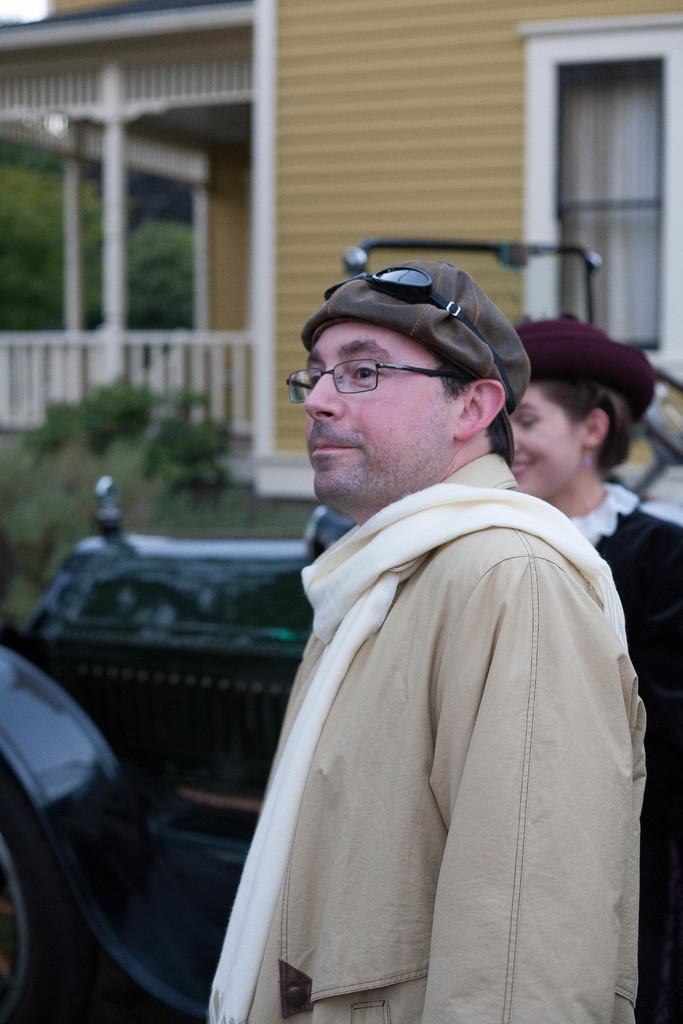How many people are in the foreground of the image? There are two persons in the foreground of the image. What else can be seen in the foreground of the image? There are vehicles on the road in the foreground of the image. What is visible in the background of the image? There is a house, house plants, and trees in the background of the image. Can you describe the time of day when the image might have been taken? The image might have been taken during the day, as there is sufficient light to see the details. How much money is being exchanged between the two persons in the image? There is no indication of any money exchange in the image; the two persons are simply standing in the foreground. 